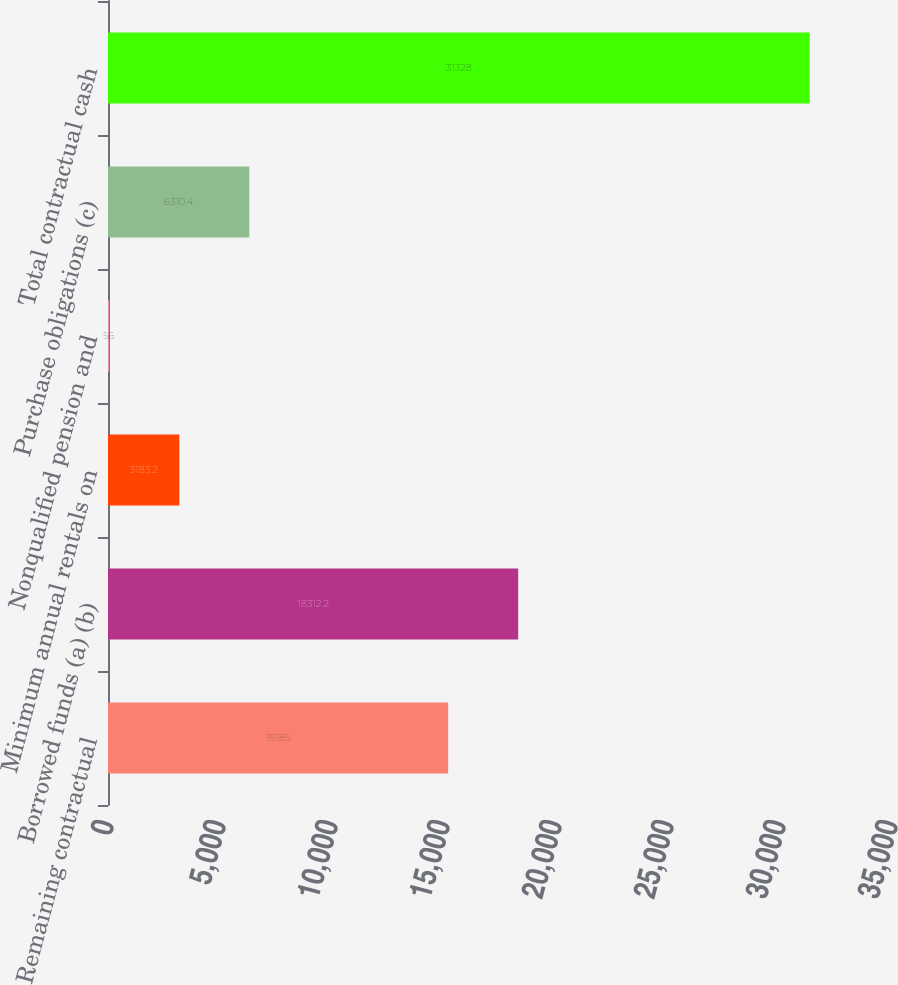Convert chart. <chart><loc_0><loc_0><loc_500><loc_500><bar_chart><fcel>Remaining contractual<fcel>Borrowed funds (a) (b)<fcel>Minimum annual rentals on<fcel>Nonqualified pension and<fcel>Purchase obligations (c)<fcel>Total contractual cash<nl><fcel>15185<fcel>18312.2<fcel>3183.2<fcel>56<fcel>6310.4<fcel>31328<nl></chart> 